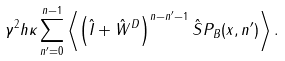Convert formula to latex. <formula><loc_0><loc_0><loc_500><loc_500>\gamma ^ { 2 } h \kappa \sum _ { n ^ { \prime } = 0 } ^ { n - 1 } \left \langle \left ( \hat { I } + \hat { W } ^ { D } \right ) ^ { n - n ^ { \prime } - 1 } \hat { S } P _ { B } ( { x } , n ^ { \prime } ) \right \rangle .</formula> 